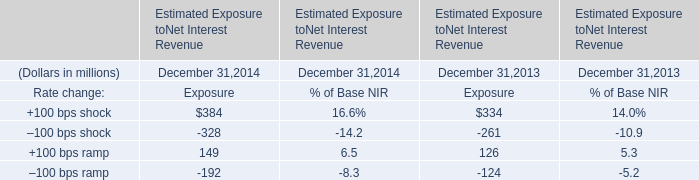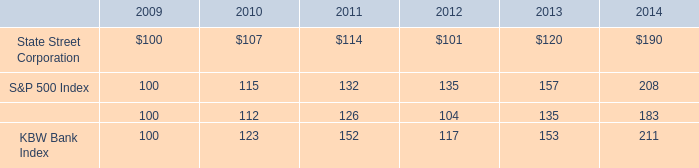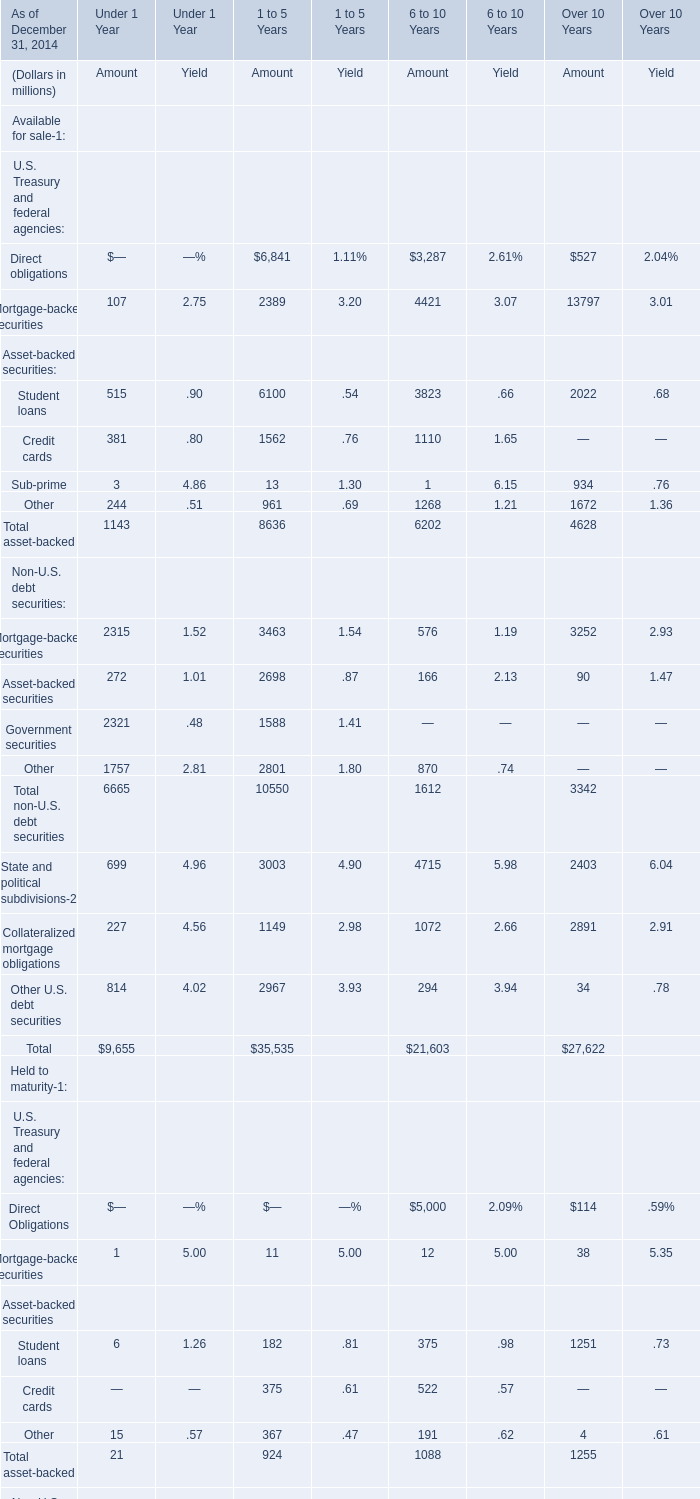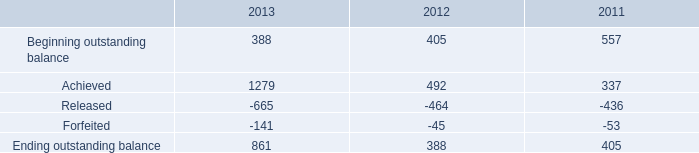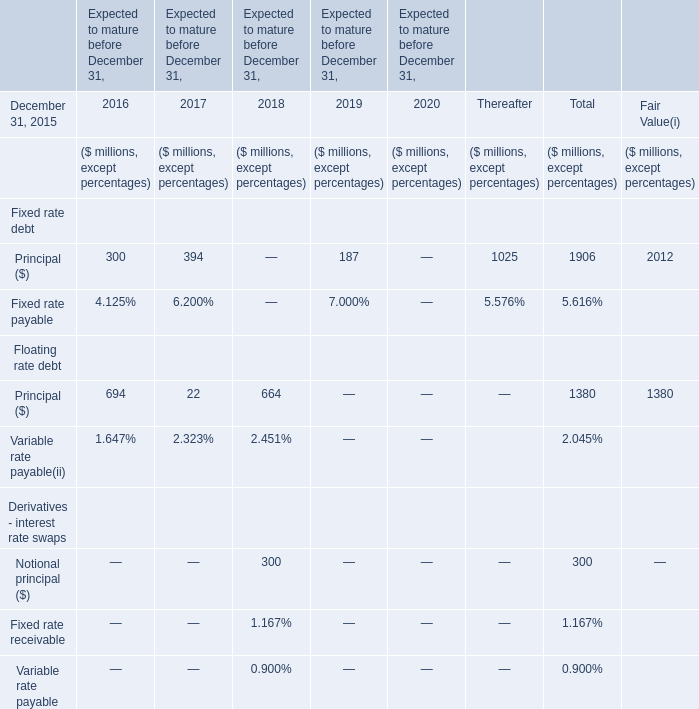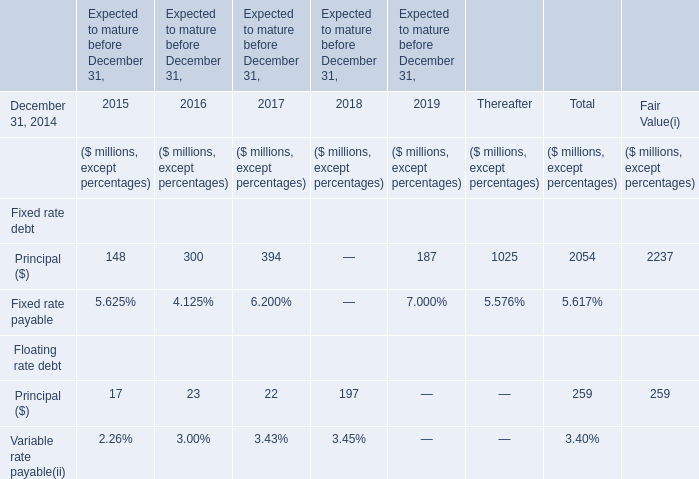what is the roi of an investment in state street corporation from 20011 to 2012? 
Computations: ((101 - 114) / 114)
Answer: -0.11404. 